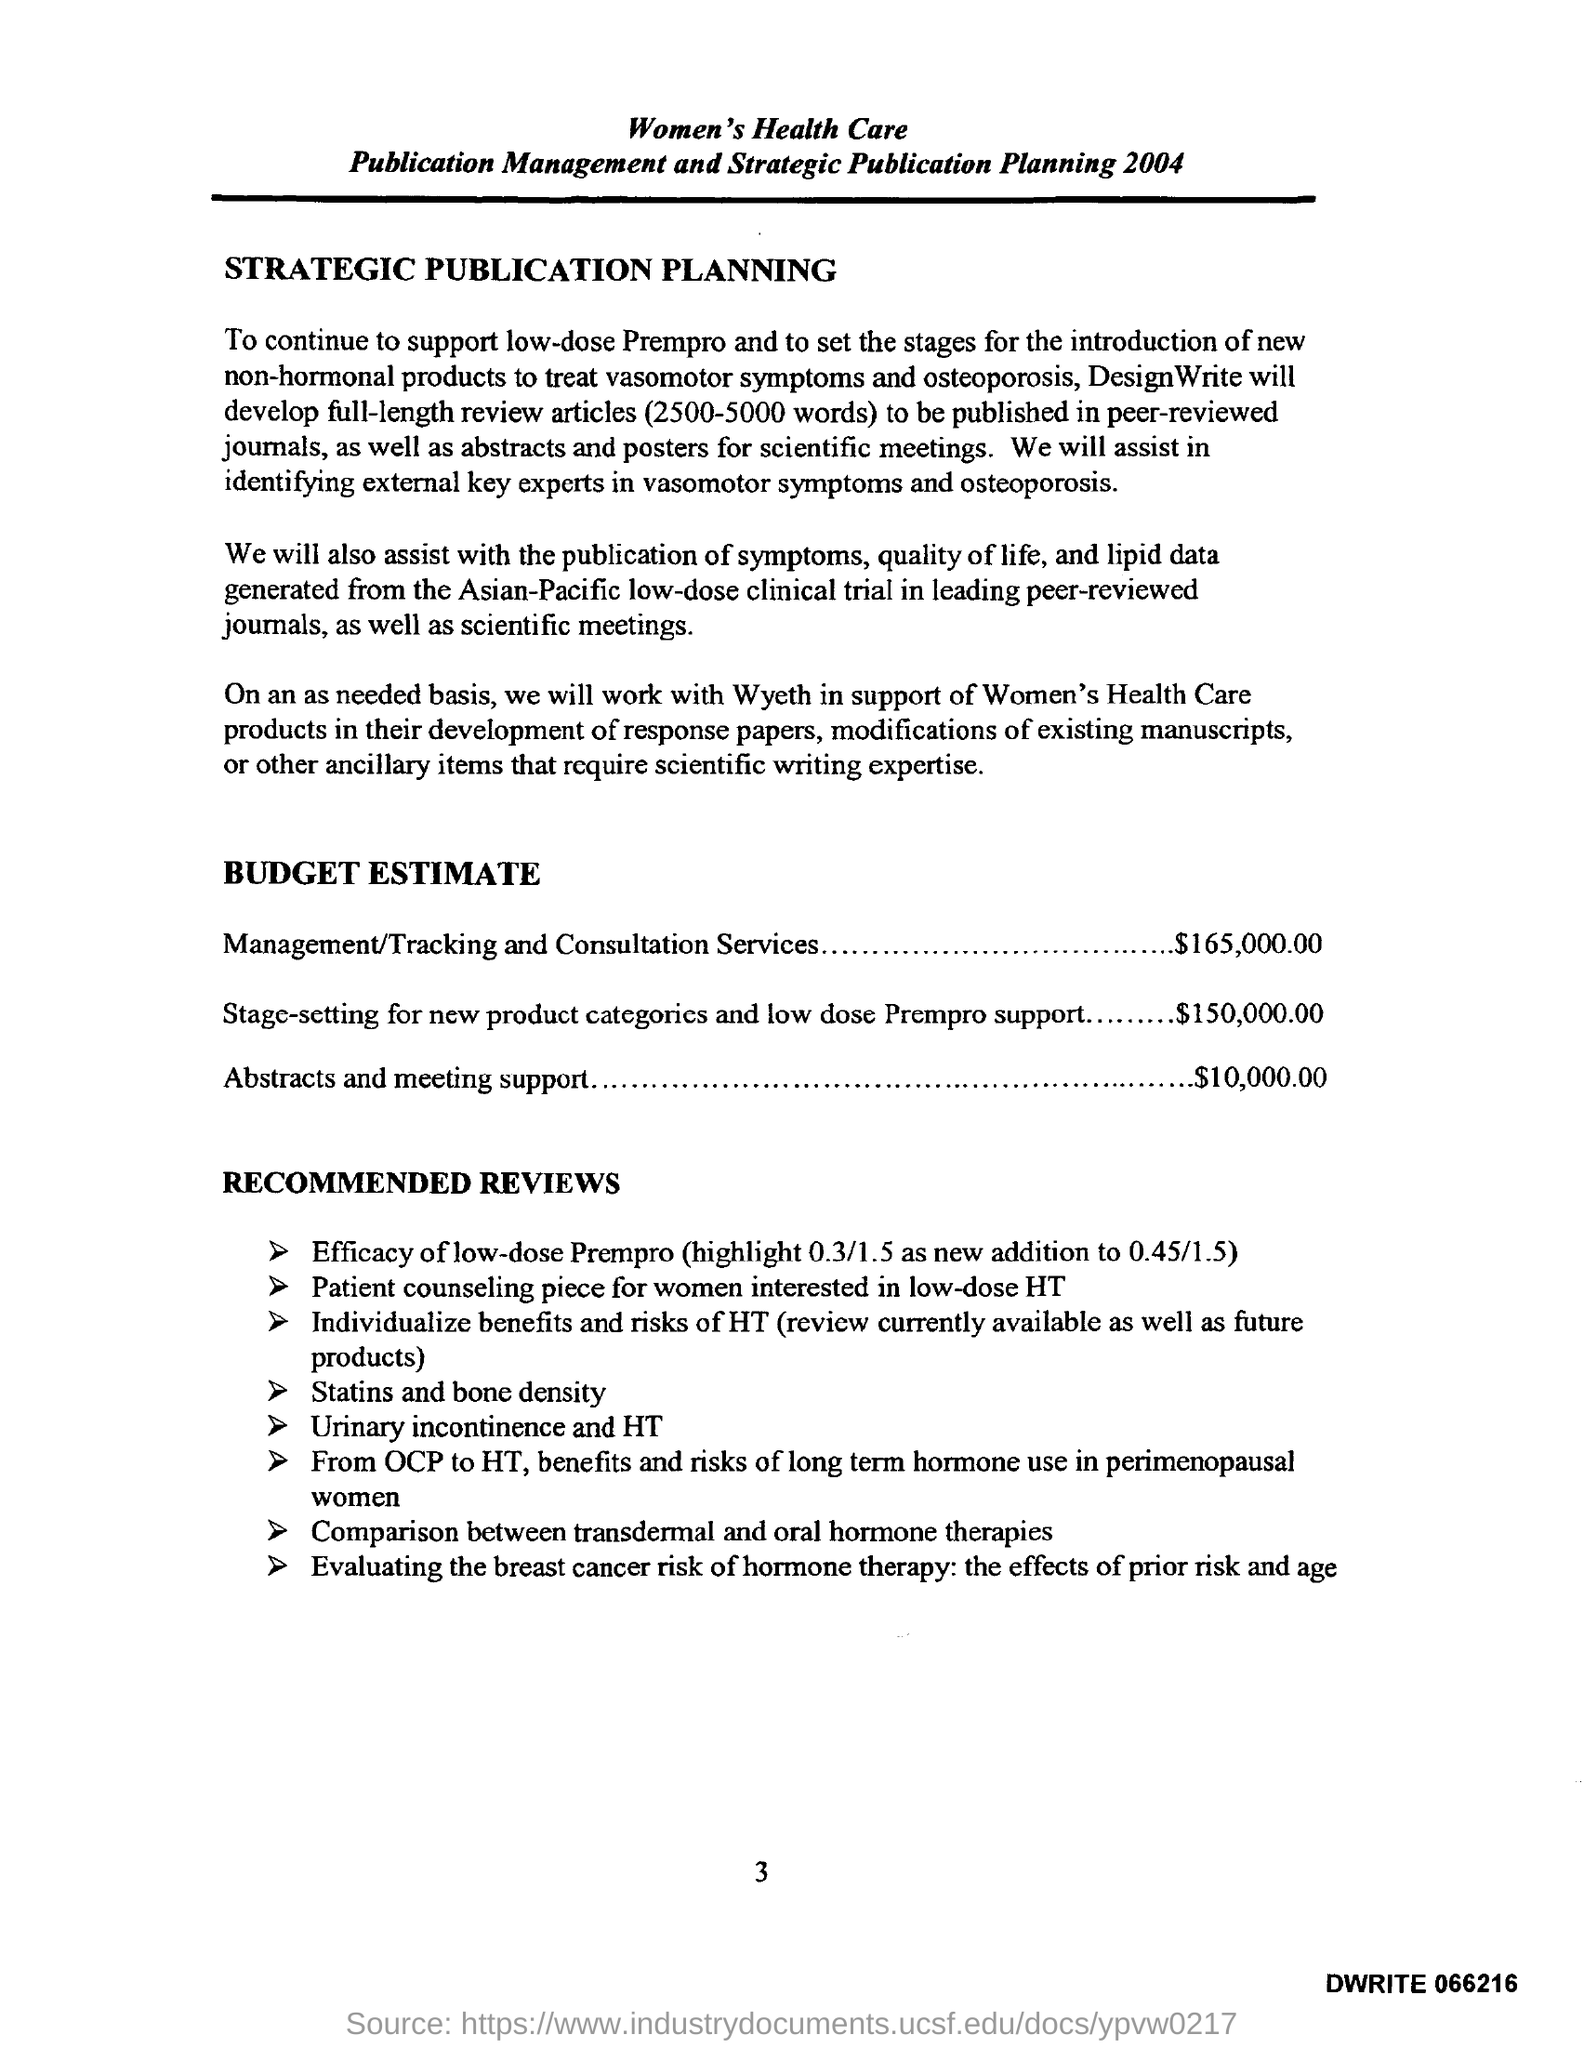What is the Budget Estimate for Abstracts and Meeting Support?
Keep it short and to the point. $10,000.00. What is the page no mentioned in this document?
Give a very brief answer. 3. What is the Budget Estimate of Stage-setting for new product categories and low dose Prempro Support?
Make the answer very short. $150,000.00. 